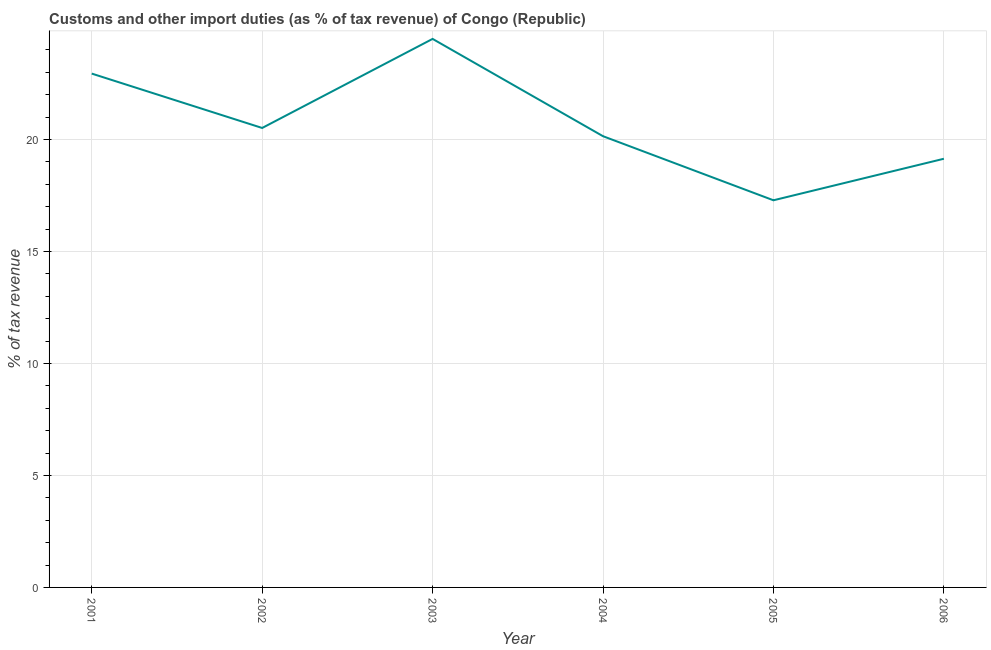What is the customs and other import duties in 2005?
Your answer should be compact. 17.28. Across all years, what is the maximum customs and other import duties?
Your answer should be compact. 24.49. Across all years, what is the minimum customs and other import duties?
Your response must be concise. 17.28. In which year was the customs and other import duties minimum?
Your answer should be very brief. 2005. What is the sum of the customs and other import duties?
Give a very brief answer. 124.5. What is the difference between the customs and other import duties in 2002 and 2003?
Provide a succinct answer. -3.98. What is the average customs and other import duties per year?
Give a very brief answer. 20.75. What is the median customs and other import duties?
Provide a succinct answer. 20.33. What is the ratio of the customs and other import duties in 2002 to that in 2005?
Make the answer very short. 1.19. What is the difference between the highest and the second highest customs and other import duties?
Ensure brevity in your answer.  1.55. Is the sum of the customs and other import duties in 2001 and 2002 greater than the maximum customs and other import duties across all years?
Provide a short and direct response. Yes. What is the difference between the highest and the lowest customs and other import duties?
Keep it short and to the point. 7.2. What is the difference between two consecutive major ticks on the Y-axis?
Give a very brief answer. 5. Are the values on the major ticks of Y-axis written in scientific E-notation?
Offer a terse response. No. Does the graph contain any zero values?
Your answer should be very brief. No. Does the graph contain grids?
Your answer should be very brief. Yes. What is the title of the graph?
Keep it short and to the point. Customs and other import duties (as % of tax revenue) of Congo (Republic). What is the label or title of the X-axis?
Your answer should be compact. Year. What is the label or title of the Y-axis?
Offer a terse response. % of tax revenue. What is the % of tax revenue of 2001?
Provide a succinct answer. 22.94. What is the % of tax revenue of 2002?
Provide a short and direct response. 20.51. What is the % of tax revenue in 2003?
Offer a terse response. 24.49. What is the % of tax revenue of 2004?
Give a very brief answer. 20.14. What is the % of tax revenue of 2005?
Offer a very short reply. 17.28. What is the % of tax revenue of 2006?
Make the answer very short. 19.14. What is the difference between the % of tax revenue in 2001 and 2002?
Offer a terse response. 2.43. What is the difference between the % of tax revenue in 2001 and 2003?
Ensure brevity in your answer.  -1.55. What is the difference between the % of tax revenue in 2001 and 2004?
Your response must be concise. 2.8. What is the difference between the % of tax revenue in 2001 and 2005?
Provide a succinct answer. 5.66. What is the difference between the % of tax revenue in 2001 and 2006?
Make the answer very short. 3.8. What is the difference between the % of tax revenue in 2002 and 2003?
Offer a very short reply. -3.98. What is the difference between the % of tax revenue in 2002 and 2004?
Provide a succinct answer. 0.37. What is the difference between the % of tax revenue in 2002 and 2005?
Make the answer very short. 3.23. What is the difference between the % of tax revenue in 2002 and 2006?
Make the answer very short. 1.37. What is the difference between the % of tax revenue in 2003 and 2004?
Provide a succinct answer. 4.34. What is the difference between the % of tax revenue in 2003 and 2005?
Your response must be concise. 7.2. What is the difference between the % of tax revenue in 2003 and 2006?
Ensure brevity in your answer.  5.35. What is the difference between the % of tax revenue in 2004 and 2005?
Your response must be concise. 2.86. What is the difference between the % of tax revenue in 2004 and 2006?
Your response must be concise. 1.01. What is the difference between the % of tax revenue in 2005 and 2006?
Offer a very short reply. -1.85. What is the ratio of the % of tax revenue in 2001 to that in 2002?
Offer a very short reply. 1.12. What is the ratio of the % of tax revenue in 2001 to that in 2003?
Offer a very short reply. 0.94. What is the ratio of the % of tax revenue in 2001 to that in 2004?
Ensure brevity in your answer.  1.14. What is the ratio of the % of tax revenue in 2001 to that in 2005?
Provide a succinct answer. 1.33. What is the ratio of the % of tax revenue in 2001 to that in 2006?
Keep it short and to the point. 1.2. What is the ratio of the % of tax revenue in 2002 to that in 2003?
Provide a succinct answer. 0.84. What is the ratio of the % of tax revenue in 2002 to that in 2005?
Offer a terse response. 1.19. What is the ratio of the % of tax revenue in 2002 to that in 2006?
Keep it short and to the point. 1.07. What is the ratio of the % of tax revenue in 2003 to that in 2004?
Provide a succinct answer. 1.22. What is the ratio of the % of tax revenue in 2003 to that in 2005?
Your response must be concise. 1.42. What is the ratio of the % of tax revenue in 2003 to that in 2006?
Ensure brevity in your answer.  1.28. What is the ratio of the % of tax revenue in 2004 to that in 2005?
Ensure brevity in your answer.  1.17. What is the ratio of the % of tax revenue in 2004 to that in 2006?
Your response must be concise. 1.05. What is the ratio of the % of tax revenue in 2005 to that in 2006?
Your response must be concise. 0.9. 